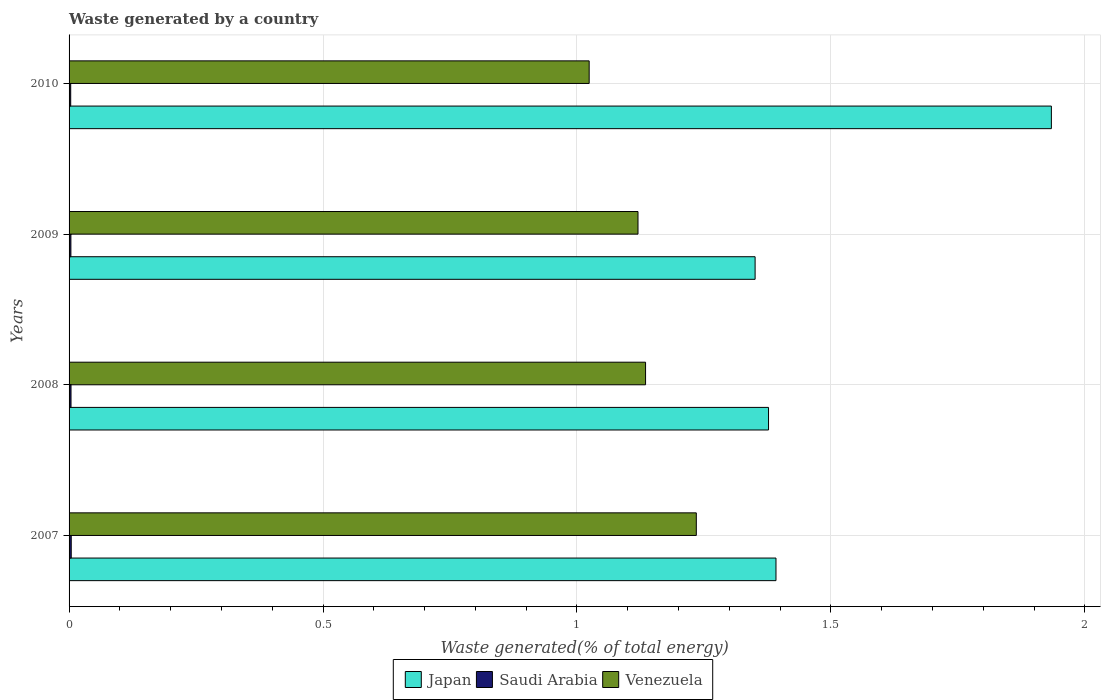How many bars are there on the 3rd tick from the bottom?
Provide a short and direct response. 3. What is the label of the 2nd group of bars from the top?
Make the answer very short. 2009. What is the total waste generated in Saudi Arabia in 2007?
Your answer should be compact. 0. Across all years, what is the maximum total waste generated in Saudi Arabia?
Provide a short and direct response. 0. Across all years, what is the minimum total waste generated in Saudi Arabia?
Your answer should be very brief. 0. In which year was the total waste generated in Saudi Arabia maximum?
Give a very brief answer. 2007. In which year was the total waste generated in Saudi Arabia minimum?
Your answer should be compact. 2010. What is the total total waste generated in Venezuela in the graph?
Give a very brief answer. 4.51. What is the difference between the total waste generated in Venezuela in 2007 and that in 2008?
Make the answer very short. 0.1. What is the difference between the total waste generated in Venezuela in 2010 and the total waste generated in Saudi Arabia in 2007?
Make the answer very short. 1.02. What is the average total waste generated in Japan per year?
Provide a succinct answer. 1.51. In the year 2008, what is the difference between the total waste generated in Saudi Arabia and total waste generated in Japan?
Your response must be concise. -1.37. What is the ratio of the total waste generated in Japan in 2009 to that in 2010?
Offer a terse response. 0.7. What is the difference between the highest and the second highest total waste generated in Venezuela?
Provide a short and direct response. 0.1. What is the difference between the highest and the lowest total waste generated in Saudi Arabia?
Give a very brief answer. 0. In how many years, is the total waste generated in Saudi Arabia greater than the average total waste generated in Saudi Arabia taken over all years?
Your answer should be very brief. 2. What does the 1st bar from the top in 2007 represents?
Give a very brief answer. Venezuela. What does the 2nd bar from the bottom in 2008 represents?
Offer a terse response. Saudi Arabia. Does the graph contain grids?
Provide a succinct answer. Yes. How many legend labels are there?
Your answer should be very brief. 3. What is the title of the graph?
Provide a succinct answer. Waste generated by a country. Does "Korea (Democratic)" appear as one of the legend labels in the graph?
Offer a very short reply. No. What is the label or title of the X-axis?
Your response must be concise. Waste generated(% of total energy). What is the label or title of the Y-axis?
Provide a succinct answer. Years. What is the Waste generated(% of total energy) in Japan in 2007?
Your answer should be very brief. 1.39. What is the Waste generated(% of total energy) of Saudi Arabia in 2007?
Give a very brief answer. 0. What is the Waste generated(% of total energy) of Venezuela in 2007?
Offer a very short reply. 1.23. What is the Waste generated(% of total energy) in Japan in 2008?
Offer a very short reply. 1.38. What is the Waste generated(% of total energy) in Saudi Arabia in 2008?
Your answer should be very brief. 0. What is the Waste generated(% of total energy) of Venezuela in 2008?
Make the answer very short. 1.14. What is the Waste generated(% of total energy) of Japan in 2009?
Your answer should be very brief. 1.35. What is the Waste generated(% of total energy) in Saudi Arabia in 2009?
Offer a very short reply. 0. What is the Waste generated(% of total energy) in Venezuela in 2009?
Provide a short and direct response. 1.12. What is the Waste generated(% of total energy) in Japan in 2010?
Your answer should be compact. 1.93. What is the Waste generated(% of total energy) in Saudi Arabia in 2010?
Your response must be concise. 0. What is the Waste generated(% of total energy) in Venezuela in 2010?
Your answer should be compact. 1.02. Across all years, what is the maximum Waste generated(% of total energy) of Japan?
Your response must be concise. 1.93. Across all years, what is the maximum Waste generated(% of total energy) in Saudi Arabia?
Your response must be concise. 0. Across all years, what is the maximum Waste generated(% of total energy) of Venezuela?
Your answer should be very brief. 1.23. Across all years, what is the minimum Waste generated(% of total energy) in Japan?
Your response must be concise. 1.35. Across all years, what is the minimum Waste generated(% of total energy) in Saudi Arabia?
Keep it short and to the point. 0. Across all years, what is the minimum Waste generated(% of total energy) in Venezuela?
Provide a short and direct response. 1.02. What is the total Waste generated(% of total energy) of Japan in the graph?
Ensure brevity in your answer.  6.05. What is the total Waste generated(% of total energy) of Saudi Arabia in the graph?
Your response must be concise. 0.01. What is the total Waste generated(% of total energy) in Venezuela in the graph?
Give a very brief answer. 4.51. What is the difference between the Waste generated(% of total energy) in Japan in 2007 and that in 2008?
Offer a very short reply. 0.01. What is the difference between the Waste generated(% of total energy) of Saudi Arabia in 2007 and that in 2008?
Offer a terse response. 0. What is the difference between the Waste generated(% of total energy) in Venezuela in 2007 and that in 2008?
Give a very brief answer. 0.1. What is the difference between the Waste generated(% of total energy) of Japan in 2007 and that in 2009?
Keep it short and to the point. 0.04. What is the difference between the Waste generated(% of total energy) in Saudi Arabia in 2007 and that in 2009?
Keep it short and to the point. 0. What is the difference between the Waste generated(% of total energy) in Venezuela in 2007 and that in 2009?
Give a very brief answer. 0.11. What is the difference between the Waste generated(% of total energy) in Japan in 2007 and that in 2010?
Make the answer very short. -0.54. What is the difference between the Waste generated(% of total energy) of Venezuela in 2007 and that in 2010?
Offer a very short reply. 0.21. What is the difference between the Waste generated(% of total energy) of Japan in 2008 and that in 2009?
Offer a very short reply. 0.03. What is the difference between the Waste generated(% of total energy) in Venezuela in 2008 and that in 2009?
Ensure brevity in your answer.  0.01. What is the difference between the Waste generated(% of total energy) in Japan in 2008 and that in 2010?
Provide a succinct answer. -0.56. What is the difference between the Waste generated(% of total energy) in Saudi Arabia in 2008 and that in 2010?
Your answer should be compact. 0. What is the difference between the Waste generated(% of total energy) in Venezuela in 2008 and that in 2010?
Keep it short and to the point. 0.11. What is the difference between the Waste generated(% of total energy) of Japan in 2009 and that in 2010?
Keep it short and to the point. -0.58. What is the difference between the Waste generated(% of total energy) in Saudi Arabia in 2009 and that in 2010?
Provide a short and direct response. 0. What is the difference between the Waste generated(% of total energy) of Venezuela in 2009 and that in 2010?
Offer a terse response. 0.1. What is the difference between the Waste generated(% of total energy) in Japan in 2007 and the Waste generated(% of total energy) in Saudi Arabia in 2008?
Your answer should be compact. 1.39. What is the difference between the Waste generated(% of total energy) of Japan in 2007 and the Waste generated(% of total energy) of Venezuela in 2008?
Keep it short and to the point. 0.26. What is the difference between the Waste generated(% of total energy) of Saudi Arabia in 2007 and the Waste generated(% of total energy) of Venezuela in 2008?
Offer a terse response. -1.13. What is the difference between the Waste generated(% of total energy) in Japan in 2007 and the Waste generated(% of total energy) in Saudi Arabia in 2009?
Provide a short and direct response. 1.39. What is the difference between the Waste generated(% of total energy) in Japan in 2007 and the Waste generated(% of total energy) in Venezuela in 2009?
Your answer should be very brief. 0.27. What is the difference between the Waste generated(% of total energy) of Saudi Arabia in 2007 and the Waste generated(% of total energy) of Venezuela in 2009?
Provide a short and direct response. -1.12. What is the difference between the Waste generated(% of total energy) in Japan in 2007 and the Waste generated(% of total energy) in Saudi Arabia in 2010?
Offer a terse response. 1.39. What is the difference between the Waste generated(% of total energy) of Japan in 2007 and the Waste generated(% of total energy) of Venezuela in 2010?
Your answer should be very brief. 0.37. What is the difference between the Waste generated(% of total energy) in Saudi Arabia in 2007 and the Waste generated(% of total energy) in Venezuela in 2010?
Your answer should be compact. -1.02. What is the difference between the Waste generated(% of total energy) in Japan in 2008 and the Waste generated(% of total energy) in Saudi Arabia in 2009?
Offer a very short reply. 1.37. What is the difference between the Waste generated(% of total energy) in Japan in 2008 and the Waste generated(% of total energy) in Venezuela in 2009?
Your answer should be very brief. 0.26. What is the difference between the Waste generated(% of total energy) in Saudi Arabia in 2008 and the Waste generated(% of total energy) in Venezuela in 2009?
Give a very brief answer. -1.12. What is the difference between the Waste generated(% of total energy) of Japan in 2008 and the Waste generated(% of total energy) of Saudi Arabia in 2010?
Keep it short and to the point. 1.37. What is the difference between the Waste generated(% of total energy) in Japan in 2008 and the Waste generated(% of total energy) in Venezuela in 2010?
Provide a succinct answer. 0.35. What is the difference between the Waste generated(% of total energy) of Saudi Arabia in 2008 and the Waste generated(% of total energy) of Venezuela in 2010?
Provide a succinct answer. -1.02. What is the difference between the Waste generated(% of total energy) in Japan in 2009 and the Waste generated(% of total energy) in Saudi Arabia in 2010?
Ensure brevity in your answer.  1.35. What is the difference between the Waste generated(% of total energy) of Japan in 2009 and the Waste generated(% of total energy) of Venezuela in 2010?
Ensure brevity in your answer.  0.33. What is the difference between the Waste generated(% of total energy) of Saudi Arabia in 2009 and the Waste generated(% of total energy) of Venezuela in 2010?
Make the answer very short. -1.02. What is the average Waste generated(% of total energy) of Japan per year?
Your answer should be very brief. 1.51. What is the average Waste generated(% of total energy) of Saudi Arabia per year?
Give a very brief answer. 0. What is the average Waste generated(% of total energy) of Venezuela per year?
Offer a terse response. 1.13. In the year 2007, what is the difference between the Waste generated(% of total energy) in Japan and Waste generated(% of total energy) in Saudi Arabia?
Keep it short and to the point. 1.39. In the year 2007, what is the difference between the Waste generated(% of total energy) in Japan and Waste generated(% of total energy) in Venezuela?
Provide a short and direct response. 0.16. In the year 2007, what is the difference between the Waste generated(% of total energy) in Saudi Arabia and Waste generated(% of total energy) in Venezuela?
Give a very brief answer. -1.23. In the year 2008, what is the difference between the Waste generated(% of total energy) in Japan and Waste generated(% of total energy) in Saudi Arabia?
Ensure brevity in your answer.  1.37. In the year 2008, what is the difference between the Waste generated(% of total energy) in Japan and Waste generated(% of total energy) in Venezuela?
Your answer should be very brief. 0.24. In the year 2008, what is the difference between the Waste generated(% of total energy) of Saudi Arabia and Waste generated(% of total energy) of Venezuela?
Your answer should be compact. -1.13. In the year 2009, what is the difference between the Waste generated(% of total energy) of Japan and Waste generated(% of total energy) of Saudi Arabia?
Your answer should be compact. 1.35. In the year 2009, what is the difference between the Waste generated(% of total energy) of Japan and Waste generated(% of total energy) of Venezuela?
Give a very brief answer. 0.23. In the year 2009, what is the difference between the Waste generated(% of total energy) of Saudi Arabia and Waste generated(% of total energy) of Venezuela?
Your answer should be very brief. -1.12. In the year 2010, what is the difference between the Waste generated(% of total energy) of Japan and Waste generated(% of total energy) of Saudi Arabia?
Offer a terse response. 1.93. In the year 2010, what is the difference between the Waste generated(% of total energy) of Japan and Waste generated(% of total energy) of Venezuela?
Your response must be concise. 0.91. In the year 2010, what is the difference between the Waste generated(% of total energy) in Saudi Arabia and Waste generated(% of total energy) in Venezuela?
Ensure brevity in your answer.  -1.02. What is the ratio of the Waste generated(% of total energy) in Japan in 2007 to that in 2008?
Your answer should be very brief. 1.01. What is the ratio of the Waste generated(% of total energy) in Saudi Arabia in 2007 to that in 2008?
Your answer should be compact. 1.12. What is the ratio of the Waste generated(% of total energy) of Venezuela in 2007 to that in 2008?
Keep it short and to the point. 1.09. What is the ratio of the Waste generated(% of total energy) in Japan in 2007 to that in 2009?
Provide a succinct answer. 1.03. What is the ratio of the Waste generated(% of total energy) in Saudi Arabia in 2007 to that in 2009?
Offer a terse response. 1.19. What is the ratio of the Waste generated(% of total energy) of Venezuela in 2007 to that in 2009?
Give a very brief answer. 1.1. What is the ratio of the Waste generated(% of total energy) in Japan in 2007 to that in 2010?
Your response must be concise. 0.72. What is the ratio of the Waste generated(% of total energy) of Saudi Arabia in 2007 to that in 2010?
Offer a very short reply. 1.32. What is the ratio of the Waste generated(% of total energy) of Venezuela in 2007 to that in 2010?
Your answer should be compact. 1.21. What is the ratio of the Waste generated(% of total energy) in Japan in 2008 to that in 2009?
Your answer should be very brief. 1.02. What is the ratio of the Waste generated(% of total energy) in Saudi Arabia in 2008 to that in 2009?
Your answer should be very brief. 1.06. What is the ratio of the Waste generated(% of total energy) in Venezuela in 2008 to that in 2009?
Keep it short and to the point. 1.01. What is the ratio of the Waste generated(% of total energy) in Japan in 2008 to that in 2010?
Make the answer very short. 0.71. What is the ratio of the Waste generated(% of total energy) in Saudi Arabia in 2008 to that in 2010?
Your response must be concise. 1.18. What is the ratio of the Waste generated(% of total energy) of Venezuela in 2008 to that in 2010?
Offer a very short reply. 1.11. What is the ratio of the Waste generated(% of total energy) in Japan in 2009 to that in 2010?
Make the answer very short. 0.7. What is the ratio of the Waste generated(% of total energy) in Saudi Arabia in 2009 to that in 2010?
Give a very brief answer. 1.11. What is the ratio of the Waste generated(% of total energy) of Venezuela in 2009 to that in 2010?
Your answer should be very brief. 1.09. What is the difference between the highest and the second highest Waste generated(% of total energy) of Japan?
Your answer should be very brief. 0.54. What is the difference between the highest and the second highest Waste generated(% of total energy) in Venezuela?
Your answer should be compact. 0.1. What is the difference between the highest and the lowest Waste generated(% of total energy) of Japan?
Keep it short and to the point. 0.58. What is the difference between the highest and the lowest Waste generated(% of total energy) of Saudi Arabia?
Your answer should be very brief. 0. What is the difference between the highest and the lowest Waste generated(% of total energy) in Venezuela?
Give a very brief answer. 0.21. 